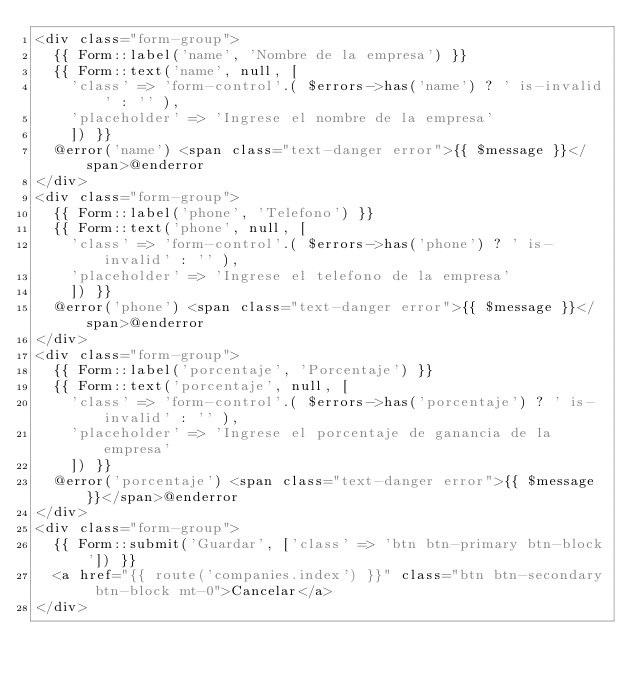Convert code to text. <code><loc_0><loc_0><loc_500><loc_500><_PHP_><div class="form-group">
	{{ Form::label('name', 'Nombre de la empresa') }}
	{{ Form::text('name', null, [
		'class' => 'form-control'.( $errors->has('name') ? ' is-invalid' : '' ),
		'placeholder' => 'Ingrese el nombre de la empresa'
		]) }}
	@error('name') <span class="text-danger error">{{ $message }}</span>@enderror
</div>
<div class="form-group">
	{{ Form::label('phone', 'Telefono') }}
	{{ Form::text('phone', null, [
		'class' => 'form-control'.( $errors->has('phone') ? ' is-invalid' : '' ),
		'placeholder' => 'Ingrese el telefono de la empresa'
		]) }}
	@error('phone') <span class="text-danger error">{{ $message }}</span>@enderror
</div>
<div class="form-group">
	{{ Form::label('porcentaje', 'Porcentaje') }}
	{{ Form::text('porcentaje', null, [
		'class' => 'form-control'.( $errors->has('porcentaje') ? ' is-invalid' : '' ),
		'placeholder' => 'Ingrese el porcentaje de ganancia de la empresa'
		]) }}
	@error('porcentaje') <span class="text-danger error">{{ $message }}</span>@enderror
</div>
<div class="form-group">
	{{ Form::submit('Guardar', ['class' => 'btn btn-primary btn-block']) }}
	<a href="{{ route('companies.index') }}" class="btn btn-secondary btn-block mt-0">Cancelar</a>
</div></code> 